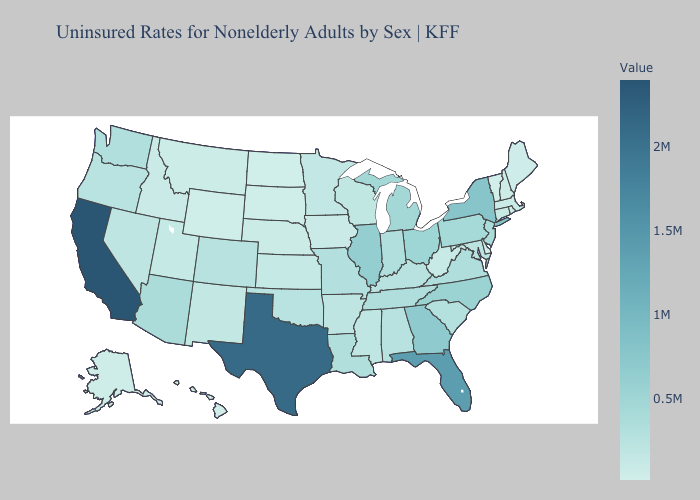Does Vermont have the lowest value in the USA?
Write a very short answer. Yes. Does North Dakota have the highest value in the USA?
Be succinct. No. Does Nevada have the highest value in the West?
Give a very brief answer. No. Does Indiana have a higher value than Georgia?
Quick response, please. No. Among the states that border North Dakota , does Minnesota have the highest value?
Write a very short answer. Yes. 